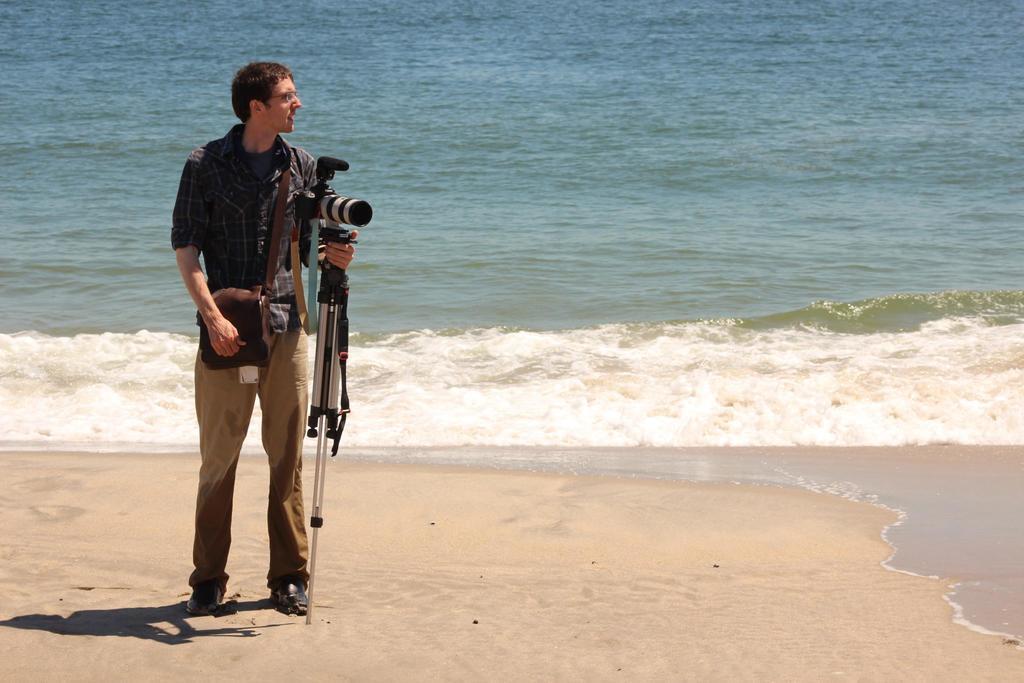Describe this image in one or two sentences. In the picture I can see a person's bag and holding the camera stand. At the bottom of the image I can see sand. In the background, I can see the water surface.  